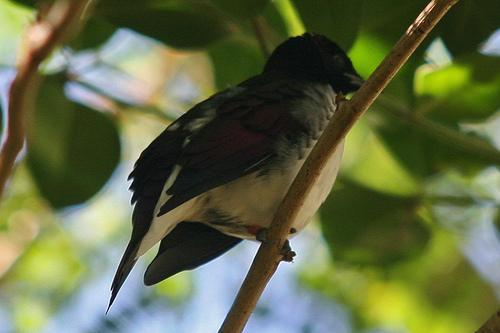Is the picture edited?
Quick response, please. No. What type of plant is the bird hiding underneath?
Answer briefly. Tree. Can this bird fly?
Short answer required. Yes. 